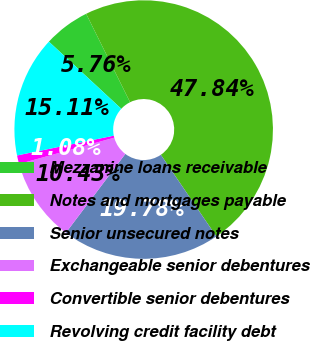Convert chart. <chart><loc_0><loc_0><loc_500><loc_500><pie_chart><fcel>Mezzanine loans receivable<fcel>Notes and mortgages payable<fcel>Senior unsecured notes<fcel>Exchangeable senior debentures<fcel>Convertible senior debentures<fcel>Revolving credit facility debt<nl><fcel>5.76%<fcel>47.84%<fcel>19.78%<fcel>10.43%<fcel>1.08%<fcel>15.11%<nl></chart> 